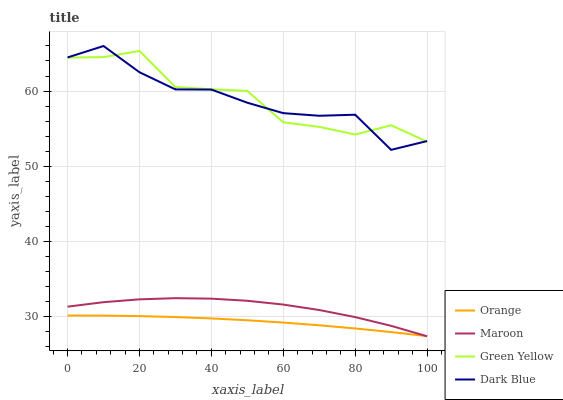Does Orange have the minimum area under the curve?
Answer yes or no. Yes. Does Green Yellow have the maximum area under the curve?
Answer yes or no. Yes. Does Dark Blue have the minimum area under the curve?
Answer yes or no. No. Does Dark Blue have the maximum area under the curve?
Answer yes or no. No. Is Orange the smoothest?
Answer yes or no. Yes. Is Green Yellow the roughest?
Answer yes or no. Yes. Is Dark Blue the smoothest?
Answer yes or no. No. Is Dark Blue the roughest?
Answer yes or no. No. Does Maroon have the lowest value?
Answer yes or no. Yes. Does Dark Blue have the lowest value?
Answer yes or no. No. Does Dark Blue have the highest value?
Answer yes or no. Yes. Does Green Yellow have the highest value?
Answer yes or no. No. Is Maroon less than Dark Blue?
Answer yes or no. Yes. Is Dark Blue greater than Maroon?
Answer yes or no. Yes. Does Orange intersect Maroon?
Answer yes or no. Yes. Is Orange less than Maroon?
Answer yes or no. No. Is Orange greater than Maroon?
Answer yes or no. No. Does Maroon intersect Dark Blue?
Answer yes or no. No. 